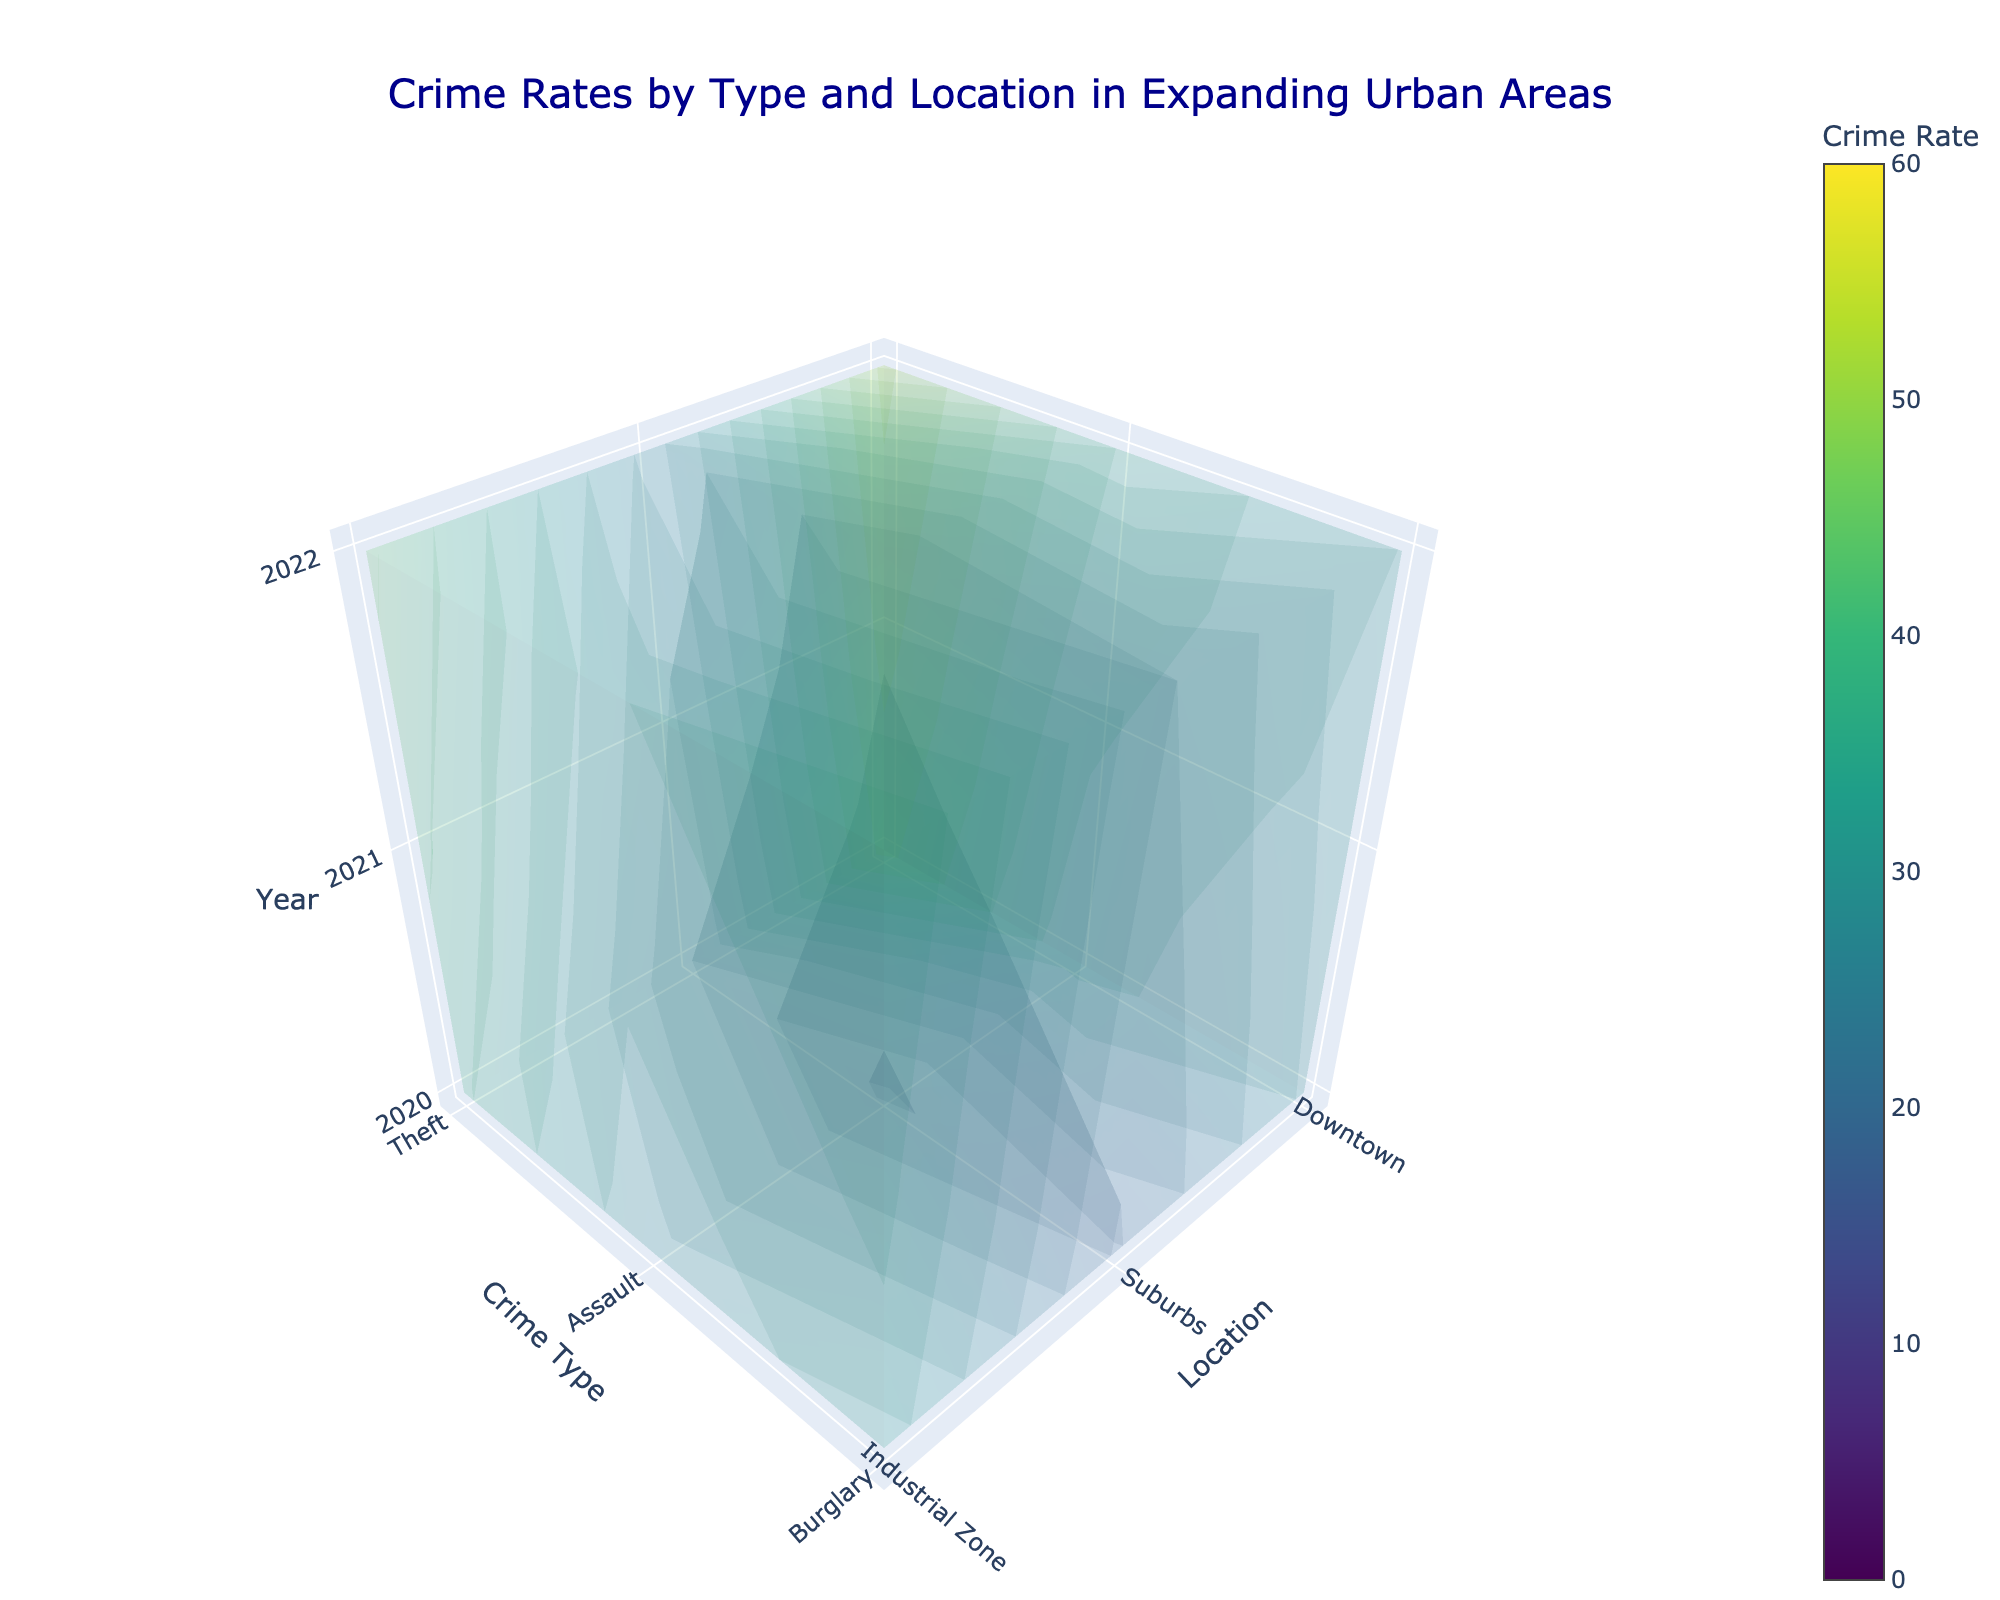what is the title of the plot? The title of the plot is displayed at the top and reads "Crime Rates by Type and Location in Expanding Urban Areas".
Answer: Crime Rates by Type and Location in Expanding Urban Areas How many years are displayed in the plot? The z-axis titled "Year" has three tick marks labeled 2020, 2021, and 2022.
Answer: 3 What is the highest crime rate value displayed in the plot? The color bar on the right side of the plot shows the range of values, with the highest being 60.
Answer: 60 Which area had the highest rate of theft in 2022? By inspecting the data points corresponding to 2022 on the z-axis and looking at the value on the color scale for theft, the Downtown area has the highest rate.
Answer: Downtown What is the trend in assault rates in the Industrial Zone from 2020 to 2022? By observing the data values along the z-axis for the Industrial Zone and the crime type Assault, it can be seen that the crime rates increase from 29.5 in 2020 to 31.8 in 2021, and then to 34.2 in 2022.
Answer: Increasing Compare the burglary rates between the Suburbs and Industrial Zone in 2021. Looking at the data points for the year 2021 on the z-axis for burglary, the rate in the Suburbs is 20.3 while in the Industrial Zone it is 35.6.
Answer: Industrial Zone has higher Which location saw the largest increase in theft rates from 2020 to 2022? By comparing the theft rates across years for each location, Downtown increased from 45.2 in 2020 to 51.3 in 2022, showing the largest increase.
Answer: Downtown What is the average crime rate for burglary in Downtown across the years shown? The burglary rates in Downtown for the years 2020, 2021, and 2022 are 28.9, 30.1, and 31.5 respectively. The average is calculated as (28.9 + 30.1 + 31.5) / 3 = 30.17.
Answer: 30.17 Are crime rates generally higher in the Suburbs or Industrial Zone for all crime types? Inspecting the values on the color scale for all crime types across years, the Industrial Zone consistently shows higher rates compared to the Suburbs.
Answer: Industrial Zone 